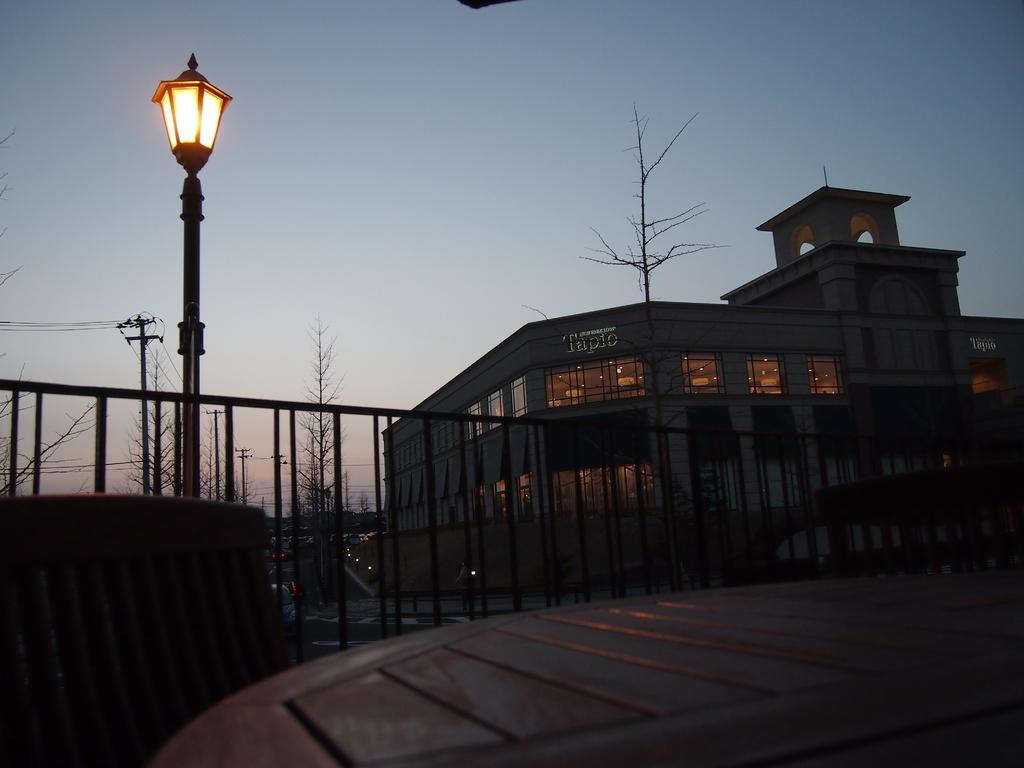What type of structure can be seen in the image? There is a light pole, a railing, and a building visible in the image. What other objects can be found in the image? There is a current pole and dried trees in the image. What is the color of the sky in the image? The sky is visible in the image, and it has a white and blue color. What type of pump can be seen in the image? There is no pump present in the image. How does the behavior of the dried trees affect the surrounding environment in the image? The image does not show any behavior of the dried trees, as they are not living organisms capable of exhibiting behavior. 